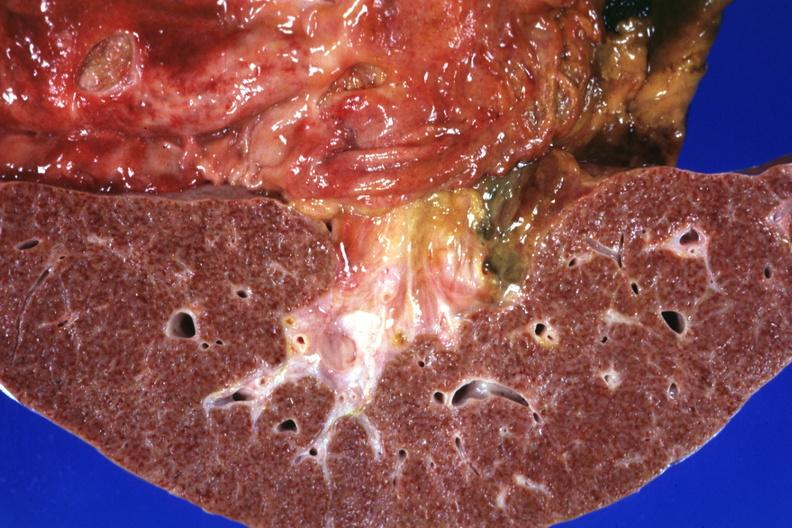s adenoma sebaceum present?
Answer the question using a single word or phrase. No 